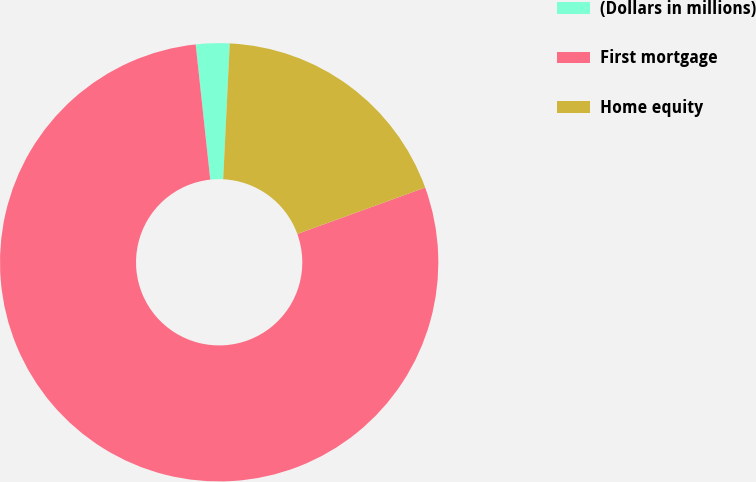Convert chart to OTSL. <chart><loc_0><loc_0><loc_500><loc_500><pie_chart><fcel>(Dollars in millions)<fcel>First mortgage<fcel>Home equity<nl><fcel>2.48%<fcel>78.83%<fcel>18.69%<nl></chart> 